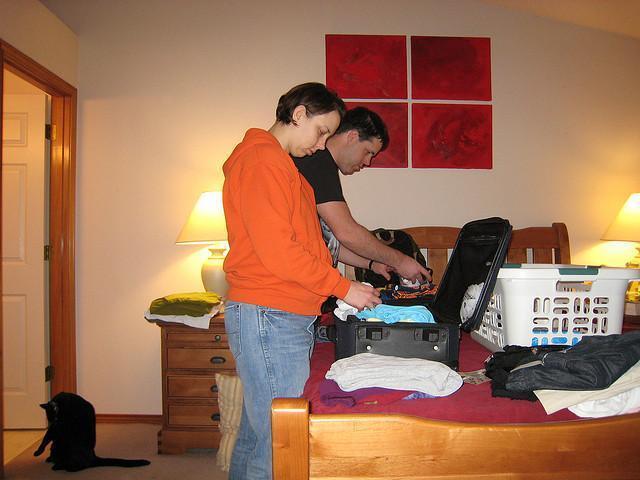How many men are there?
Give a very brief answer. 1. How many people are in the photo?
Give a very brief answer. 2. 